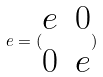<formula> <loc_0><loc_0><loc_500><loc_500>e = ( \begin{matrix} e & 0 \\ 0 & e \end{matrix} )</formula> 